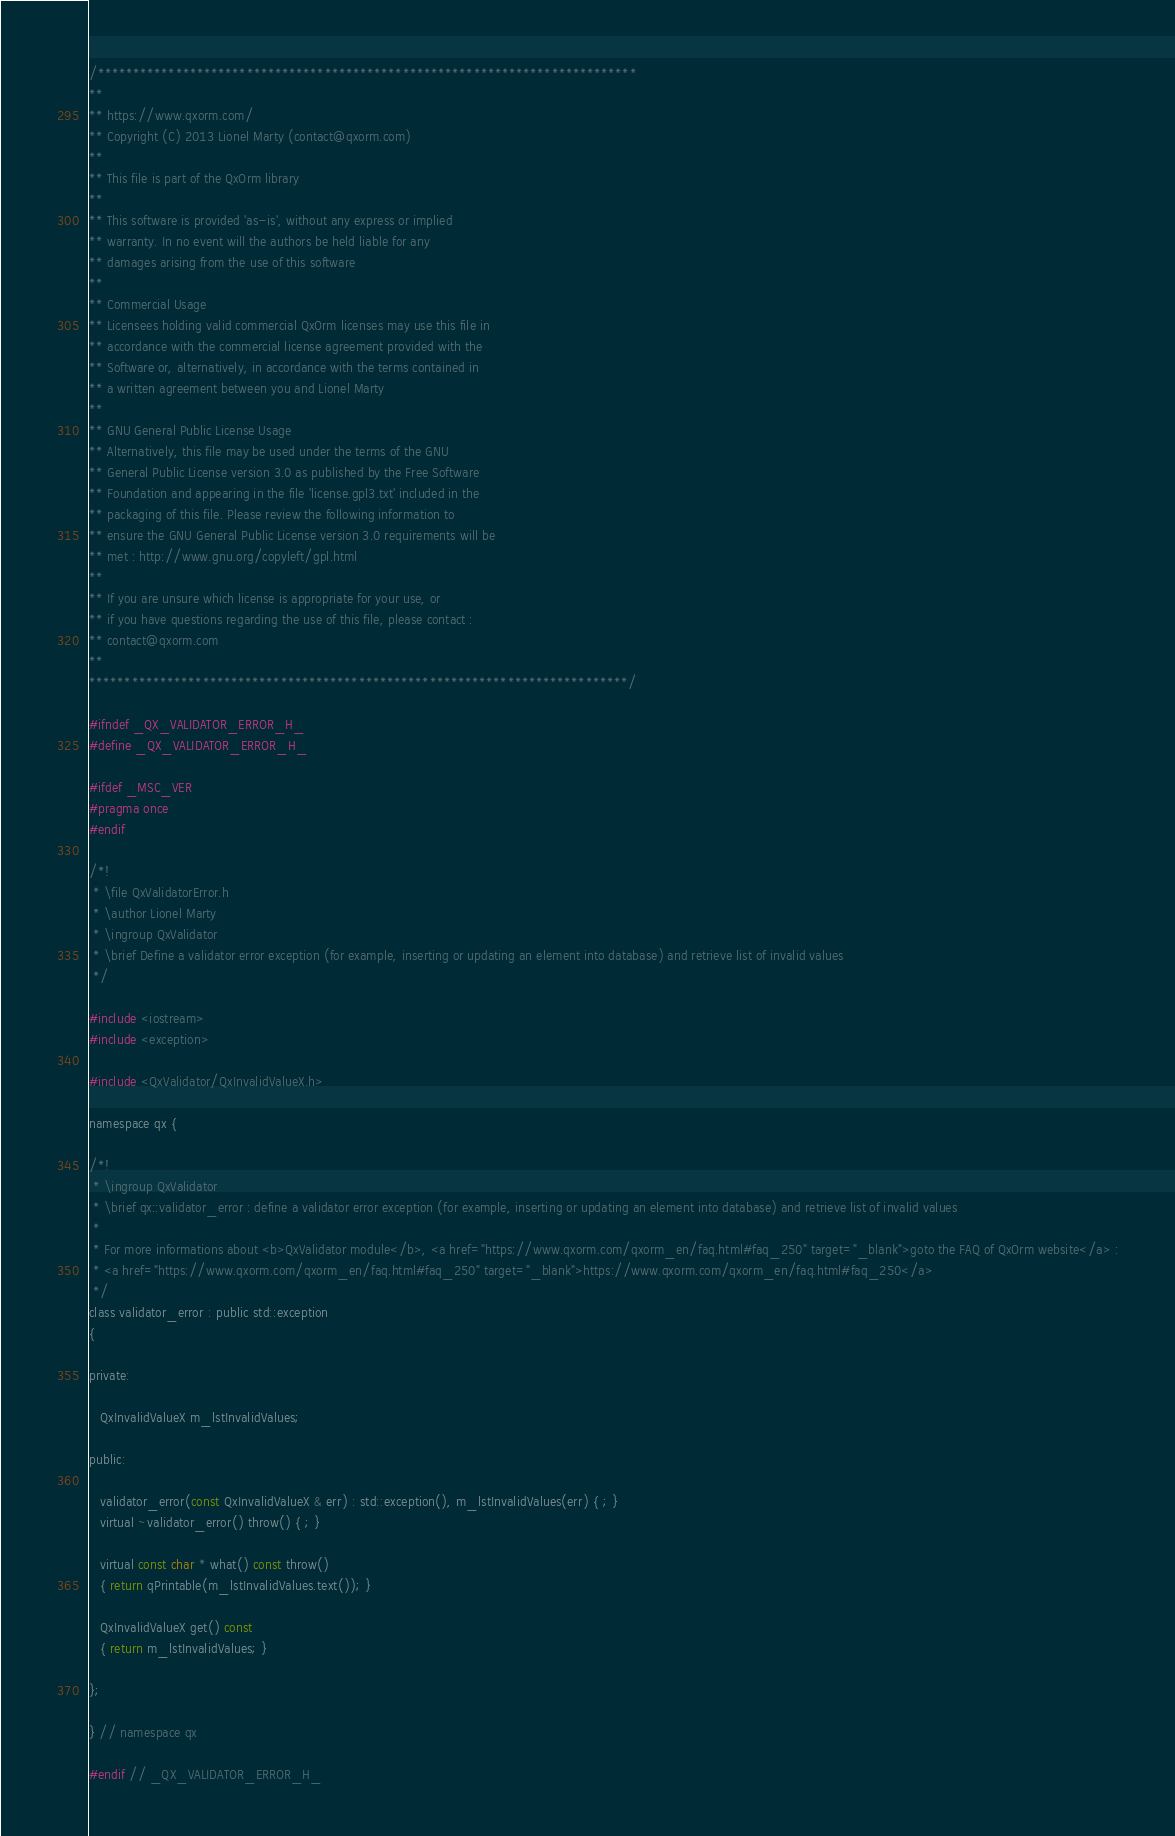Convert code to text. <code><loc_0><loc_0><loc_500><loc_500><_C_>/****************************************************************************
**
** https://www.qxorm.com/
** Copyright (C) 2013 Lionel Marty (contact@qxorm.com)
**
** This file is part of the QxOrm library
**
** This software is provided 'as-is', without any express or implied
** warranty. In no event will the authors be held liable for any
** damages arising from the use of this software
**
** Commercial Usage
** Licensees holding valid commercial QxOrm licenses may use this file in
** accordance with the commercial license agreement provided with the
** Software or, alternatively, in accordance with the terms contained in
** a written agreement between you and Lionel Marty
**
** GNU General Public License Usage
** Alternatively, this file may be used under the terms of the GNU
** General Public License version 3.0 as published by the Free Software
** Foundation and appearing in the file 'license.gpl3.txt' included in the
** packaging of this file. Please review the following information to
** ensure the GNU General Public License version 3.0 requirements will be
** met : http://www.gnu.org/copyleft/gpl.html
**
** If you are unsure which license is appropriate for your use, or
** if you have questions regarding the use of this file, please contact :
** contact@qxorm.com
**
****************************************************************************/

#ifndef _QX_VALIDATOR_ERROR_H_
#define _QX_VALIDATOR_ERROR_H_

#ifdef _MSC_VER
#pragma once
#endif

/*!
 * \file QxValidatorError.h
 * \author Lionel Marty
 * \ingroup QxValidator
 * \brief Define a validator error exception (for example, inserting or updating an element into database) and retrieve list of invalid values
 */

#include <iostream>
#include <exception>

#include <QxValidator/QxInvalidValueX.h>

namespace qx {

/*!
 * \ingroup QxValidator
 * \brief qx::validator_error : define a validator error exception (for example, inserting or updating an element into database) and retrieve list of invalid values
 *
 * For more informations about <b>QxValidator module</b>, <a href="https://www.qxorm.com/qxorm_en/faq.html#faq_250" target="_blank">goto the FAQ of QxOrm website</a> :
 * <a href="https://www.qxorm.com/qxorm_en/faq.html#faq_250" target="_blank">https://www.qxorm.com/qxorm_en/faq.html#faq_250</a>
 */
class validator_error : public std::exception
{

private:

   QxInvalidValueX m_lstInvalidValues;

public:

   validator_error(const QxInvalidValueX & err) : std::exception(), m_lstInvalidValues(err) { ; }
   virtual ~validator_error() throw() { ; }

   virtual const char * what() const throw()
   { return qPrintable(m_lstInvalidValues.text()); }

   QxInvalidValueX get() const
   { return m_lstInvalidValues; }

};

} // namespace qx

#endif // _QX_VALIDATOR_ERROR_H_
</code> 